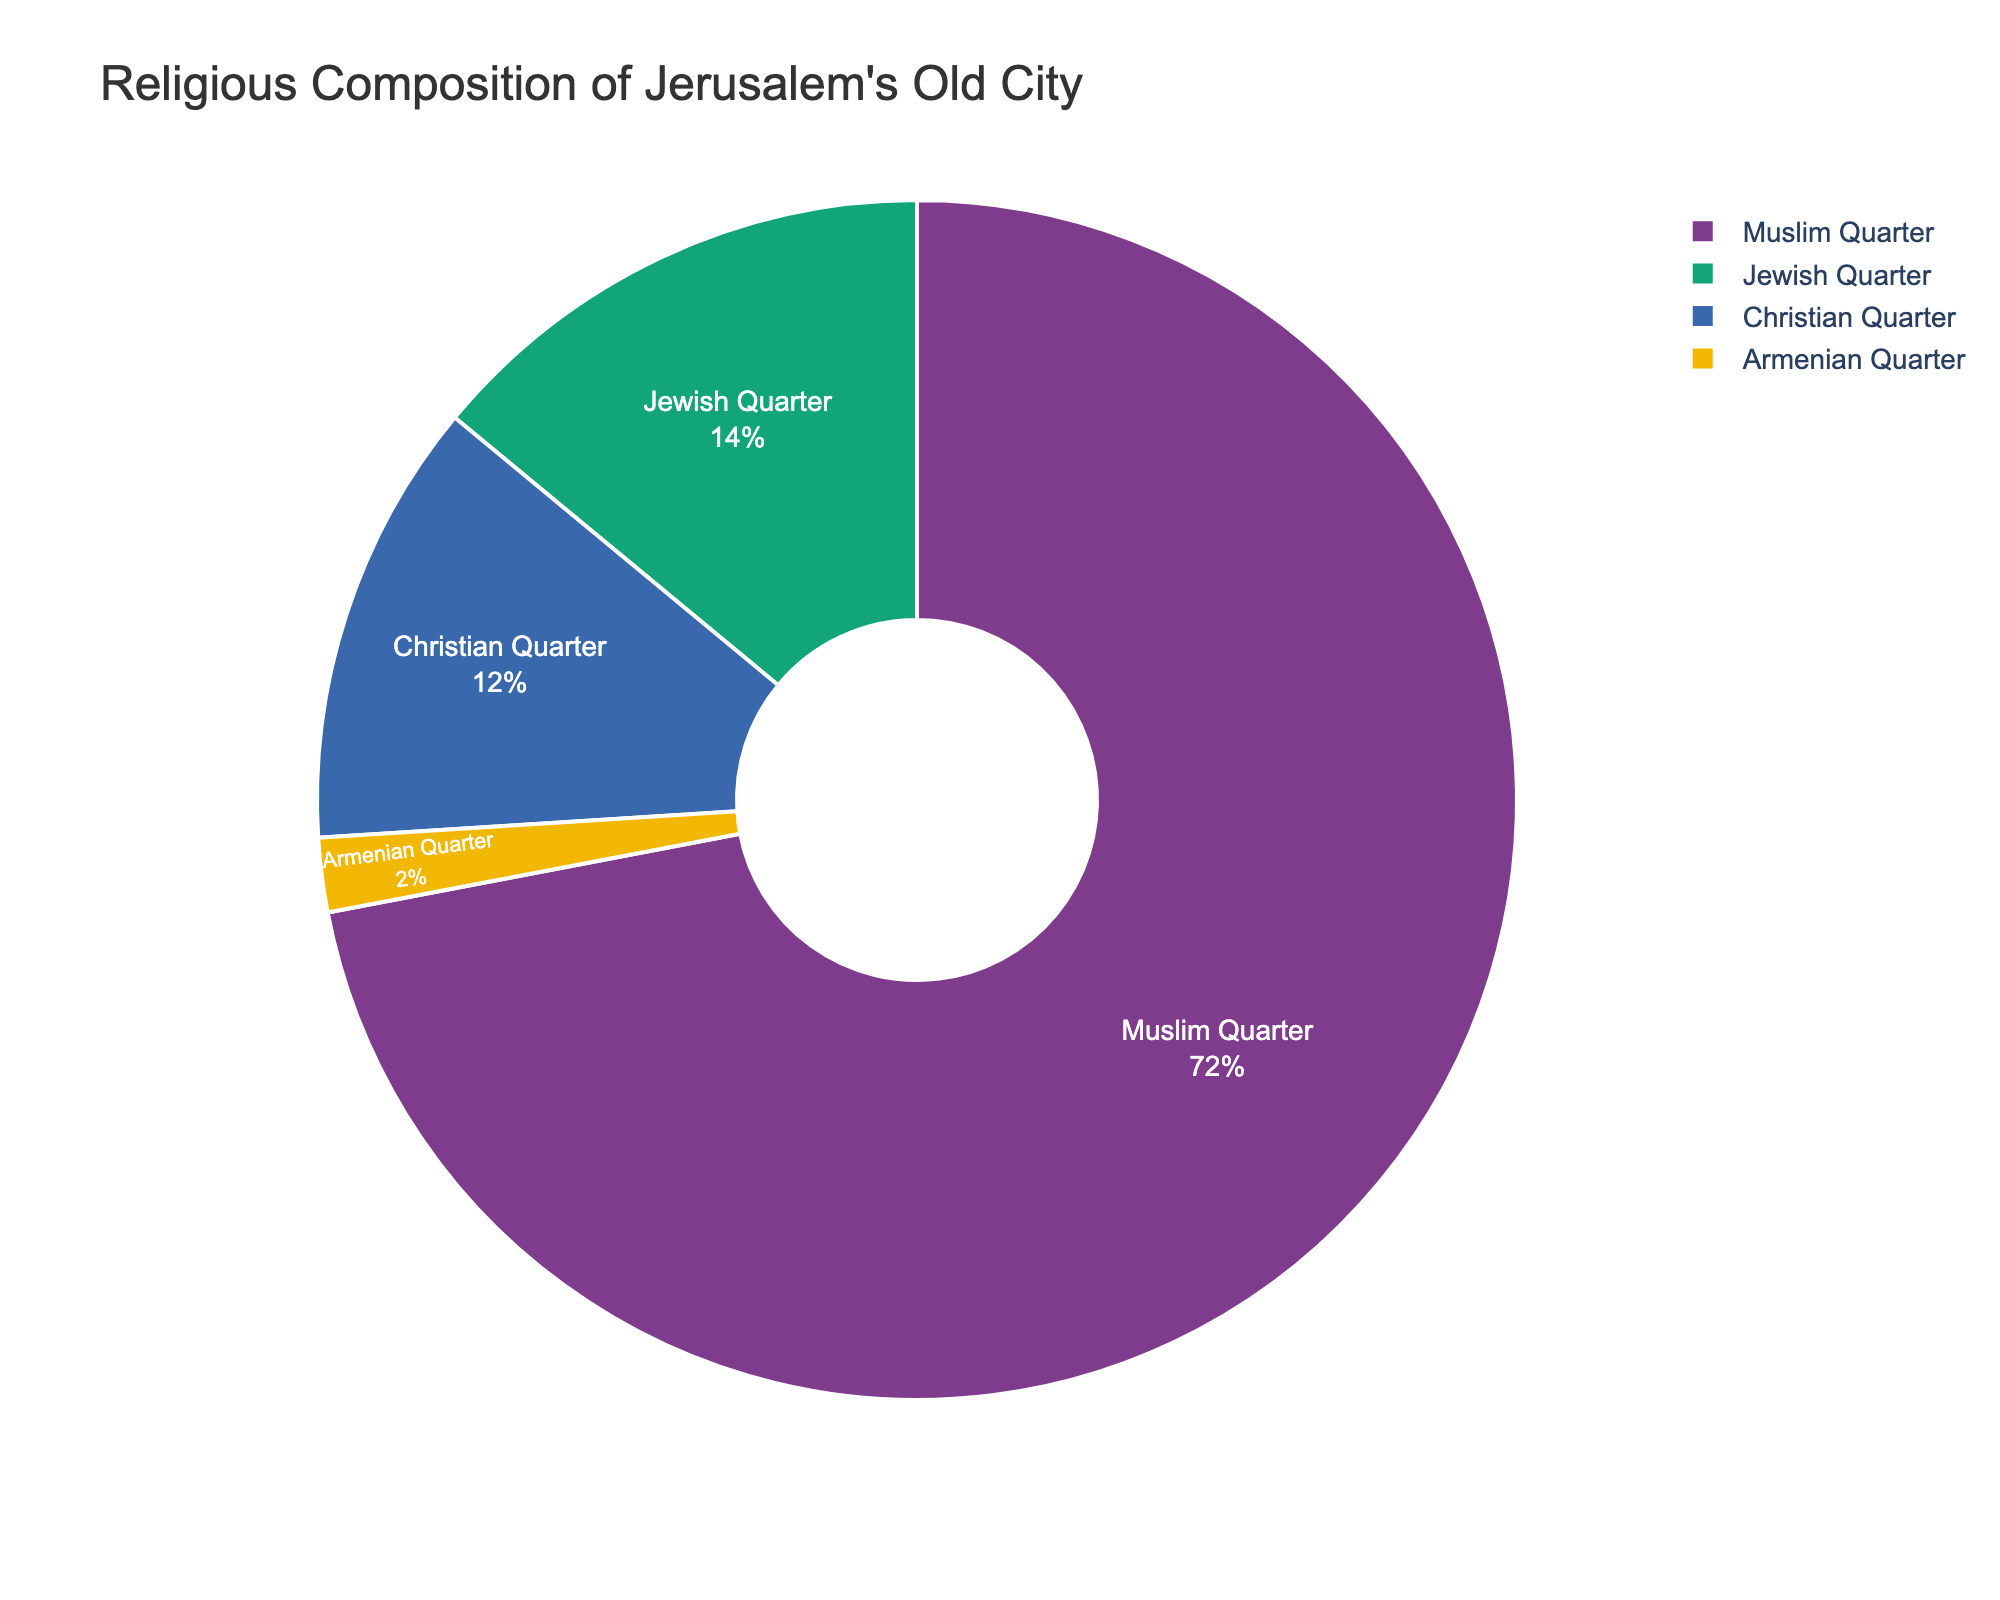What's the total population percentage for the Christian and Muslim Quarters combined? First, extract the population percentages for the Christian and Muslim Quarters: 12% and 72%, respectively. Add these percentages together: 12 + 72 = 84
Answer: 84 Which quarter has the smallest population percentage? Compare the population percentages of all quarters: Armenian (2%), Jewish (14%), Muslim (72%), and Christian (12%). The Armenian Quarter has the smallest percentage at 2%.
Answer: Armenian Quarter How much larger is the population percentage of the Muslim Quarter compared to the Jewish Quarter? Subtract the population percentage of the Jewish Quarter (14%) from the Muslim Quarter (72%): 72 - 14 = 58
Answer: 58 What fraction of the total population does the Armenian Quarter represent, in simplest form? The Armenian Quarter represents 2% of the total population. To express this percentage as a fraction, write it as 2/100 and simplify it: 2/100 = 1/50
Answer: 1/50 Which quarters together make up less than 20% of the population? Compare the population percentages: Armenian (2%), Jewish (14%), Christian (12%), and Muslim (72%). The Armenian and Jewish Quarters together make up 2 + 14 = 16, which is less than 20%.
Answer: Armenian and Jewish Quarters If you combine the Christian and Armenian Quarters, will their total population percentage be more or less than that of the Jewish Quarter? First, add the population percentages of the Christian and Armenian Quarters: 12 + 2 = 14. Now, compare it with the percentage of the Jewish Quarter, which is also 14. They are equal.
Answer: Equal Looking at the chart, which quarter dominates the religious composition of Jerusalem's Old City visually? Visually, the Muslim Quarter dominates the chart as it occupies the largest section, representing 72% of the population.
Answer: Muslim Quarter By how much does the population percentage of the Christian Quarter exceed that of the Armenian Quarter? Subtract the population percentage of the Armenian Quarter (2%) from the Christian Quarter (12%): 12 - 2 = 10
Answer: 10 What percentage of the total population do the quarters other than the Muslim Quarter represent? Subtract the population percentage of the Muslim Quarter from 100%: 100 - 72 = 28
Answer: 28 Which two quarters together make up exactly one-fourth of the total population? One-fourth of the total population is 100% / 4 = 25%. The Armenian and Christian Quarters together make up 2 + 12 = 14%, which is less. The Jewish and Armenian Quarters together make up 14 + 2 = 16%, which is also less. The Christian and Jewish Quarters together make up 12 + 14 = 26%, which is more. Thus, no two quarters make up exactly one-fourth.
Answer: None 